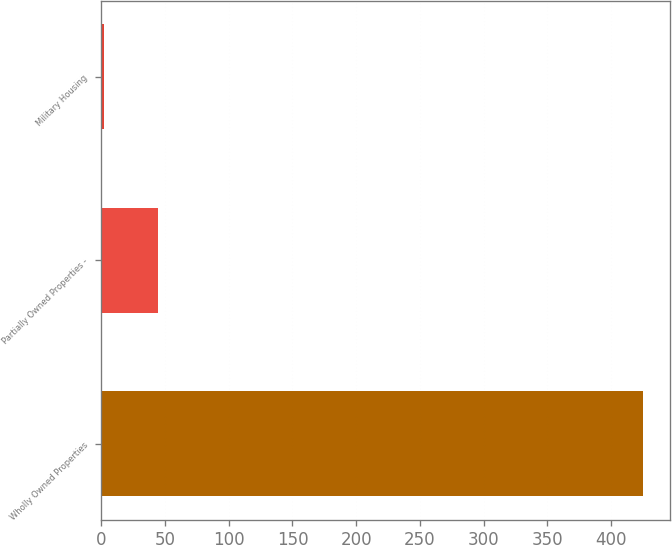<chart> <loc_0><loc_0><loc_500><loc_500><bar_chart><fcel>Wholly Owned Properties<fcel>Partially Owned Properties -<fcel>Military Housing<nl><fcel>425<fcel>44.3<fcel>2<nl></chart> 